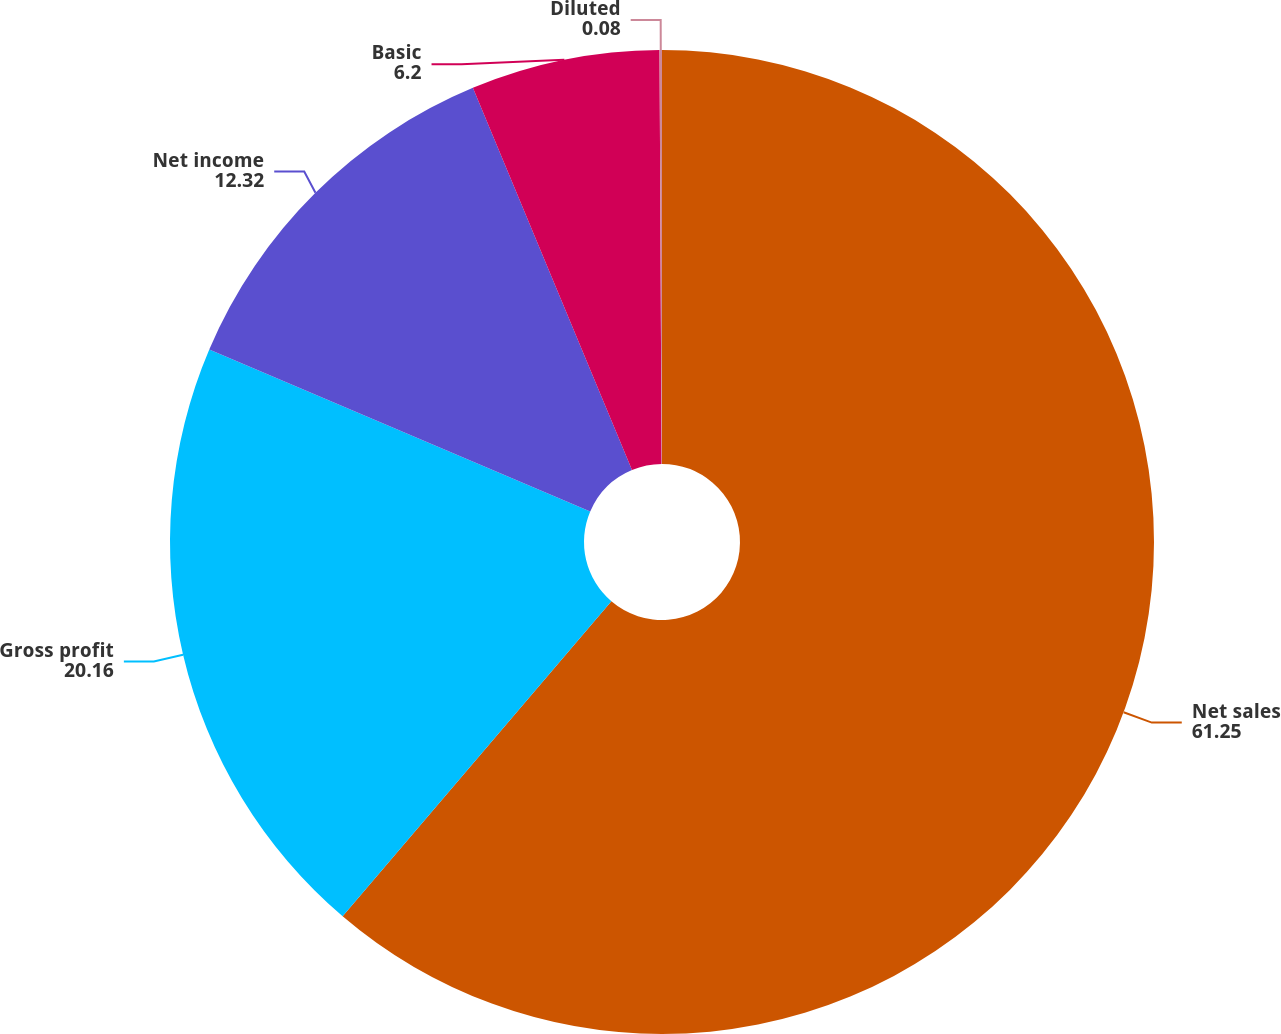Convert chart to OTSL. <chart><loc_0><loc_0><loc_500><loc_500><pie_chart><fcel>Net sales<fcel>Gross profit<fcel>Net income<fcel>Basic<fcel>Diluted<nl><fcel>61.25%<fcel>20.16%<fcel>12.32%<fcel>6.2%<fcel>0.08%<nl></chart> 